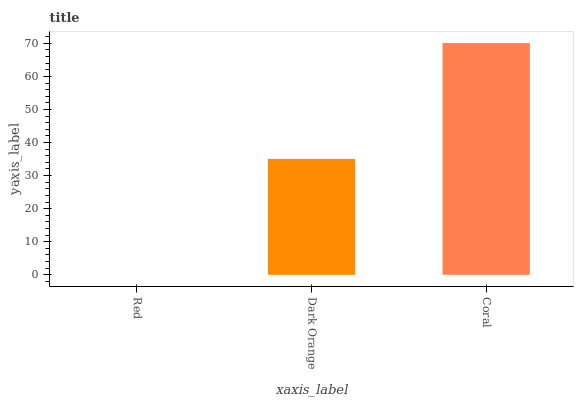Is Red the minimum?
Answer yes or no. Yes. Is Coral the maximum?
Answer yes or no. Yes. Is Dark Orange the minimum?
Answer yes or no. No. Is Dark Orange the maximum?
Answer yes or no. No. Is Dark Orange greater than Red?
Answer yes or no. Yes. Is Red less than Dark Orange?
Answer yes or no. Yes. Is Red greater than Dark Orange?
Answer yes or no. No. Is Dark Orange less than Red?
Answer yes or no. No. Is Dark Orange the high median?
Answer yes or no. Yes. Is Dark Orange the low median?
Answer yes or no. Yes. Is Red the high median?
Answer yes or no. No. Is Red the low median?
Answer yes or no. No. 